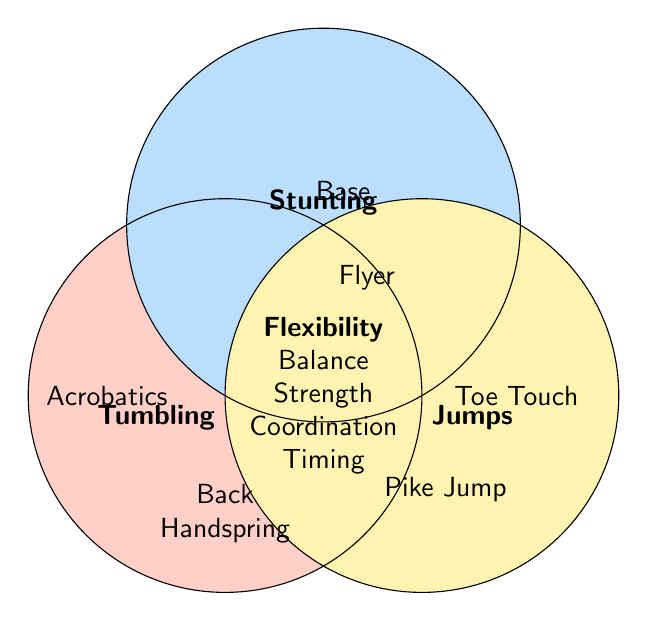What skill in Tumbling overlaps with Flexibility? The Venn Diagram shows a shared part of Tumbling and the intersection area, which includes Flexibility.
Answer: Back Handspring Which Cheerleading category has a skill that overlaps for Balance and Pike Jump? The overlapping part between Tumbling and Jumps includes certain skills; to see Balance and Pike Jump, check their overlapping category.
Answer: Tumbling What skill can be found in both Tumbling and Jumps and requires Coordination? From the Venn Diagram, locate the overlap between Tumbling and Jumps to find Coordination.
Answer: Round Off Which skill under Jumps emphasizes Timing? To find the answer, check under Jumps for the skill mentioned as emphasizing Timing.
Answer: Split Jump What skill from Stunting is also important for a Spotter's Coordination? Coordination skills are listed in the intersection; find the related Stunting skill.
Answer: Spotter How many skills overlap among all three categories? Look at the intersection area where all three circles (Tumbling, Stunting, and Jumps) meet and count the skills listed there.
Answer: 5 Which skill in Tumbling is crucial for Flyers? Check the overlap between Tumbling and Stunting for the skill relevant to Flyers.
Answer: Back Handspring What set and skill combination implies the base relies on Strength? Review Stunting skills involving Strength and locate the related set.
Answer: Base Which stunting skill aligns with Acrobatics from Tumbling? Find the overlap between the Tumbling skill Acrobatics and any Stunting skill.
Answer: Flyer 